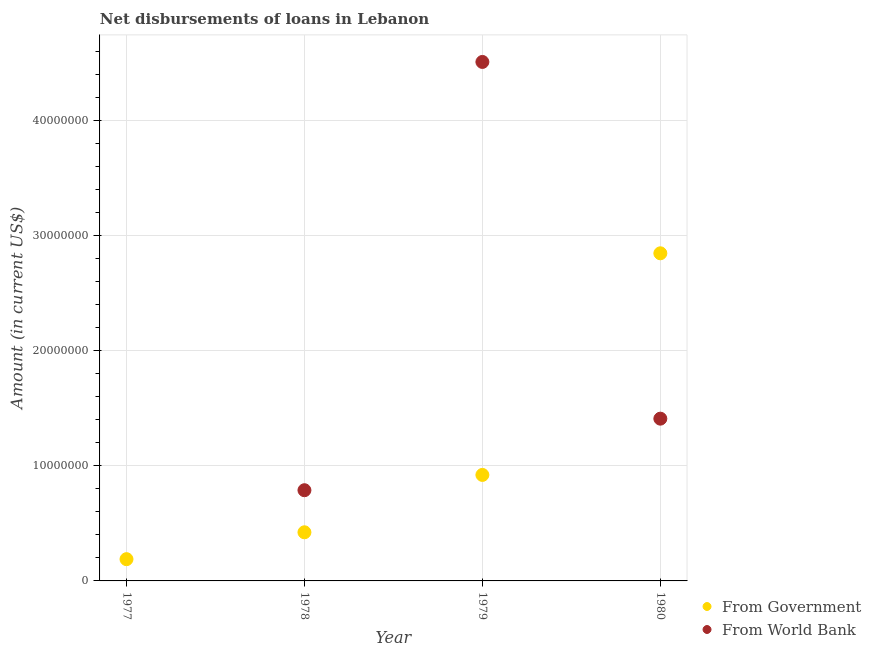Is the number of dotlines equal to the number of legend labels?
Make the answer very short. No. What is the net disbursements of loan from world bank in 1978?
Your answer should be very brief. 7.88e+06. Across all years, what is the maximum net disbursements of loan from government?
Keep it short and to the point. 2.85e+07. Across all years, what is the minimum net disbursements of loan from government?
Provide a succinct answer. 1.89e+06. What is the total net disbursements of loan from government in the graph?
Offer a terse response. 4.38e+07. What is the difference between the net disbursements of loan from government in 1978 and that in 1979?
Your response must be concise. -4.98e+06. What is the difference between the net disbursements of loan from world bank in 1978 and the net disbursements of loan from government in 1977?
Keep it short and to the point. 5.99e+06. What is the average net disbursements of loan from government per year?
Make the answer very short. 1.09e+07. In the year 1980, what is the difference between the net disbursements of loan from government and net disbursements of loan from world bank?
Offer a very short reply. 1.44e+07. In how many years, is the net disbursements of loan from world bank greater than 10000000 US$?
Your answer should be very brief. 2. What is the ratio of the net disbursements of loan from world bank in 1978 to that in 1980?
Offer a terse response. 0.56. What is the difference between the highest and the second highest net disbursements of loan from government?
Offer a very short reply. 1.93e+07. What is the difference between the highest and the lowest net disbursements of loan from world bank?
Offer a very short reply. 4.51e+07. In how many years, is the net disbursements of loan from government greater than the average net disbursements of loan from government taken over all years?
Offer a terse response. 1. Does the net disbursements of loan from government monotonically increase over the years?
Provide a succinct answer. Yes. Is the net disbursements of loan from world bank strictly greater than the net disbursements of loan from government over the years?
Keep it short and to the point. No. Is the net disbursements of loan from government strictly less than the net disbursements of loan from world bank over the years?
Your answer should be compact. No. What is the difference between two consecutive major ticks on the Y-axis?
Ensure brevity in your answer.  1.00e+07. Are the values on the major ticks of Y-axis written in scientific E-notation?
Make the answer very short. No. How many legend labels are there?
Give a very brief answer. 2. How are the legend labels stacked?
Provide a succinct answer. Vertical. What is the title of the graph?
Provide a short and direct response. Net disbursements of loans in Lebanon. Does "Urban" appear as one of the legend labels in the graph?
Your response must be concise. No. What is the Amount (in current US$) in From Government in 1977?
Make the answer very short. 1.89e+06. What is the Amount (in current US$) in From Government in 1978?
Ensure brevity in your answer.  4.22e+06. What is the Amount (in current US$) of From World Bank in 1978?
Your response must be concise. 7.88e+06. What is the Amount (in current US$) in From Government in 1979?
Offer a terse response. 9.21e+06. What is the Amount (in current US$) in From World Bank in 1979?
Offer a very short reply. 4.51e+07. What is the Amount (in current US$) in From Government in 1980?
Offer a terse response. 2.85e+07. What is the Amount (in current US$) of From World Bank in 1980?
Make the answer very short. 1.41e+07. Across all years, what is the maximum Amount (in current US$) of From Government?
Ensure brevity in your answer.  2.85e+07. Across all years, what is the maximum Amount (in current US$) of From World Bank?
Provide a short and direct response. 4.51e+07. Across all years, what is the minimum Amount (in current US$) of From Government?
Your answer should be compact. 1.89e+06. What is the total Amount (in current US$) in From Government in the graph?
Your answer should be compact. 4.38e+07. What is the total Amount (in current US$) of From World Bank in the graph?
Ensure brevity in your answer.  6.71e+07. What is the difference between the Amount (in current US$) in From Government in 1977 and that in 1978?
Your response must be concise. -2.34e+06. What is the difference between the Amount (in current US$) in From Government in 1977 and that in 1979?
Your answer should be compact. -7.32e+06. What is the difference between the Amount (in current US$) of From Government in 1977 and that in 1980?
Ensure brevity in your answer.  -2.66e+07. What is the difference between the Amount (in current US$) in From Government in 1978 and that in 1979?
Provide a short and direct response. -4.98e+06. What is the difference between the Amount (in current US$) in From World Bank in 1978 and that in 1979?
Your answer should be compact. -3.72e+07. What is the difference between the Amount (in current US$) of From Government in 1978 and that in 1980?
Give a very brief answer. -2.42e+07. What is the difference between the Amount (in current US$) of From World Bank in 1978 and that in 1980?
Give a very brief answer. -6.22e+06. What is the difference between the Amount (in current US$) in From Government in 1979 and that in 1980?
Give a very brief answer. -1.93e+07. What is the difference between the Amount (in current US$) of From World Bank in 1979 and that in 1980?
Offer a terse response. 3.10e+07. What is the difference between the Amount (in current US$) of From Government in 1977 and the Amount (in current US$) of From World Bank in 1978?
Provide a short and direct response. -5.99e+06. What is the difference between the Amount (in current US$) of From Government in 1977 and the Amount (in current US$) of From World Bank in 1979?
Make the answer very short. -4.32e+07. What is the difference between the Amount (in current US$) in From Government in 1977 and the Amount (in current US$) in From World Bank in 1980?
Offer a very short reply. -1.22e+07. What is the difference between the Amount (in current US$) in From Government in 1978 and the Amount (in current US$) in From World Bank in 1979?
Give a very brief answer. -4.09e+07. What is the difference between the Amount (in current US$) of From Government in 1978 and the Amount (in current US$) of From World Bank in 1980?
Make the answer very short. -9.87e+06. What is the difference between the Amount (in current US$) in From Government in 1979 and the Amount (in current US$) in From World Bank in 1980?
Provide a short and direct response. -4.89e+06. What is the average Amount (in current US$) of From Government per year?
Your response must be concise. 1.09e+07. What is the average Amount (in current US$) in From World Bank per year?
Your answer should be very brief. 1.68e+07. In the year 1978, what is the difference between the Amount (in current US$) of From Government and Amount (in current US$) of From World Bank?
Provide a succinct answer. -3.65e+06. In the year 1979, what is the difference between the Amount (in current US$) in From Government and Amount (in current US$) in From World Bank?
Give a very brief answer. -3.59e+07. In the year 1980, what is the difference between the Amount (in current US$) of From Government and Amount (in current US$) of From World Bank?
Give a very brief answer. 1.44e+07. What is the ratio of the Amount (in current US$) of From Government in 1977 to that in 1978?
Provide a succinct answer. 0.45. What is the ratio of the Amount (in current US$) of From Government in 1977 to that in 1979?
Your answer should be compact. 0.21. What is the ratio of the Amount (in current US$) in From Government in 1977 to that in 1980?
Your answer should be compact. 0.07. What is the ratio of the Amount (in current US$) of From Government in 1978 to that in 1979?
Offer a very short reply. 0.46. What is the ratio of the Amount (in current US$) in From World Bank in 1978 to that in 1979?
Ensure brevity in your answer.  0.17. What is the ratio of the Amount (in current US$) in From Government in 1978 to that in 1980?
Your response must be concise. 0.15. What is the ratio of the Amount (in current US$) of From World Bank in 1978 to that in 1980?
Offer a very short reply. 0.56. What is the ratio of the Amount (in current US$) of From Government in 1979 to that in 1980?
Your answer should be very brief. 0.32. What is the ratio of the Amount (in current US$) of From World Bank in 1979 to that in 1980?
Your response must be concise. 3.2. What is the difference between the highest and the second highest Amount (in current US$) in From Government?
Ensure brevity in your answer.  1.93e+07. What is the difference between the highest and the second highest Amount (in current US$) in From World Bank?
Your answer should be compact. 3.10e+07. What is the difference between the highest and the lowest Amount (in current US$) of From Government?
Your answer should be compact. 2.66e+07. What is the difference between the highest and the lowest Amount (in current US$) in From World Bank?
Ensure brevity in your answer.  4.51e+07. 